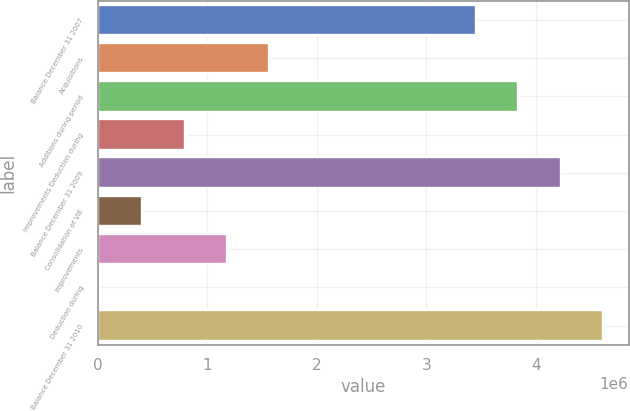Convert chart to OTSL. <chart><loc_0><loc_0><loc_500><loc_500><bar_chart><fcel>Balance December 31 2007<fcel>Acquisitions<fcel>Additions during period<fcel>Improvements Deduction during<fcel>Balance December 31 2009<fcel>Consolidation of VIE<fcel>Improvements<fcel>Deduction during<fcel>Balance December 31 2010<nl><fcel>3.45285e+06<fcel>1.56653e+06<fcel>3.84108e+06<fcel>790058<fcel>4.22932e+06<fcel>401822<fcel>1.17829e+06<fcel>13587<fcel>4.61755e+06<nl></chart> 